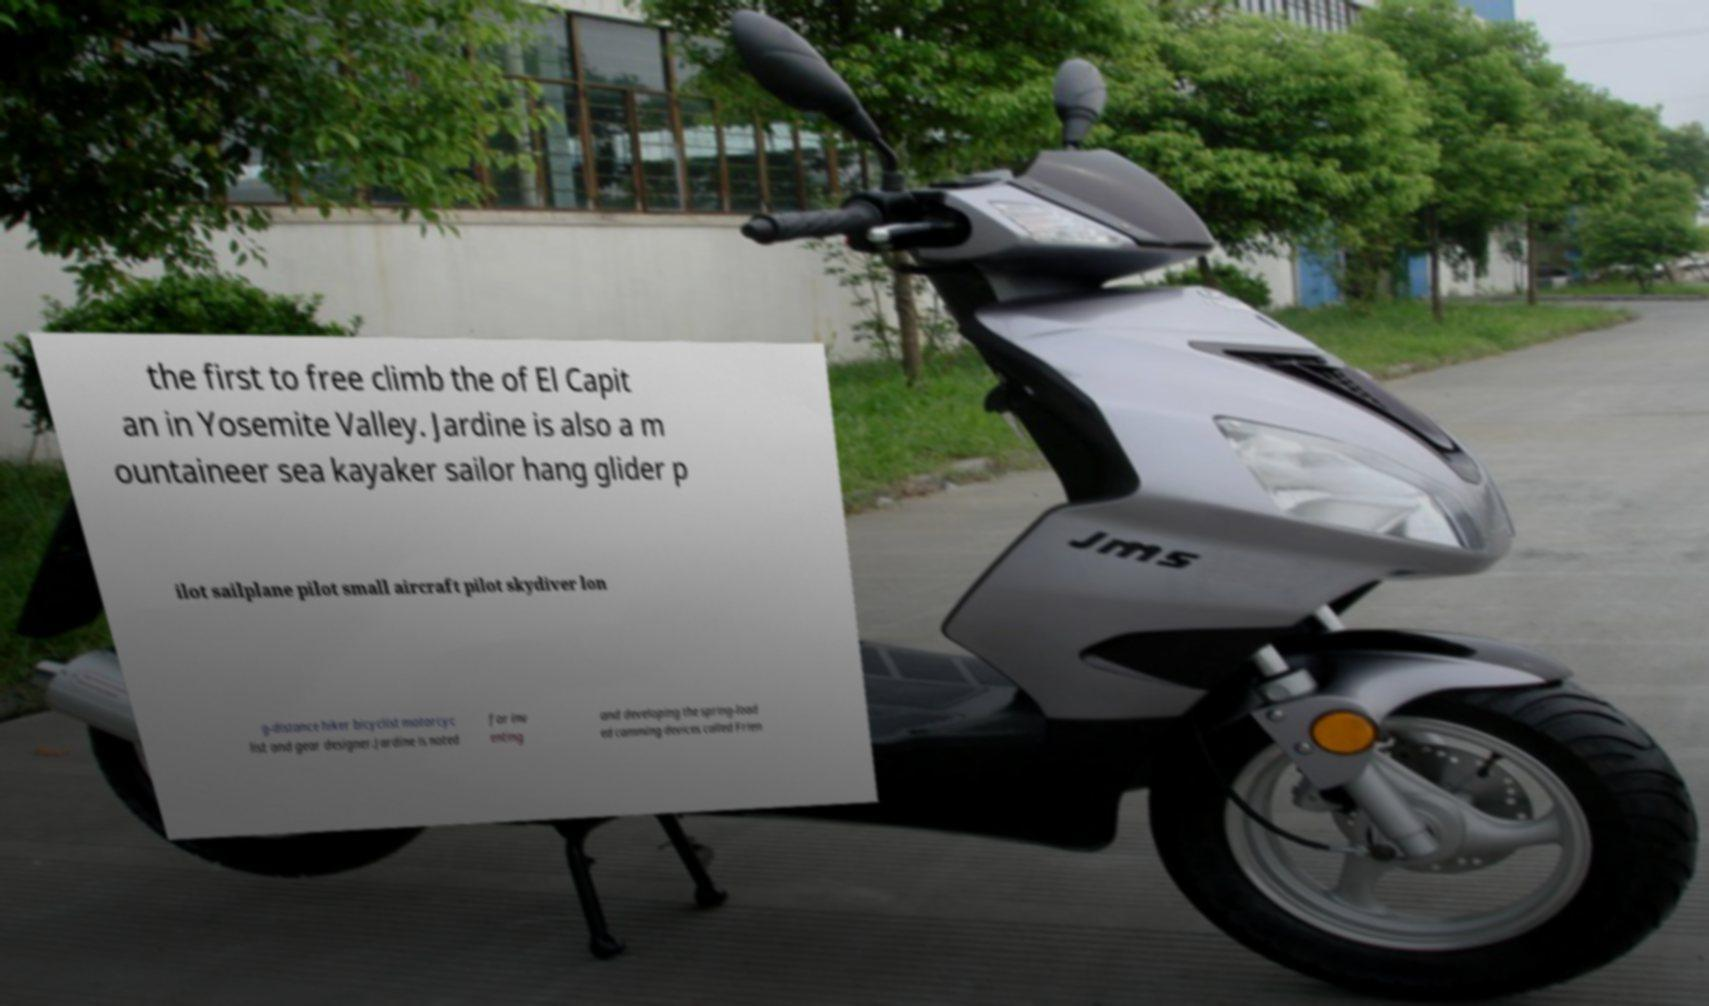Could you assist in decoding the text presented in this image and type it out clearly? the first to free climb the of El Capit an in Yosemite Valley. Jardine is also a m ountaineer sea kayaker sailor hang glider p ilot sailplane pilot small aircraft pilot skydiver lon g-distance hiker bicyclist motorcyc list and gear designer.Jardine is noted for inv enting and developing the spring-load ed camming devices called Frien 